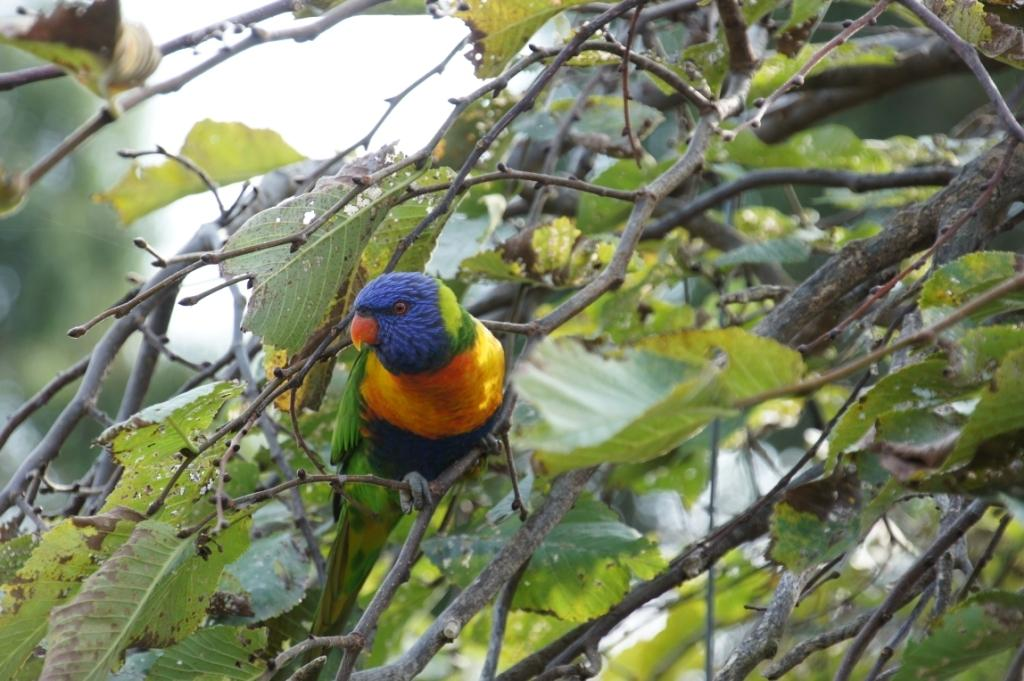What type of animal is in the image? There is a parrot in the image. Where is the parrot located? The parrot is on a tree. Is the parrot driving a car in the image? No, the parrot is not driving a car in the image; it is on a tree. 